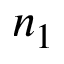<formula> <loc_0><loc_0><loc_500><loc_500>n _ { 1 }</formula> 